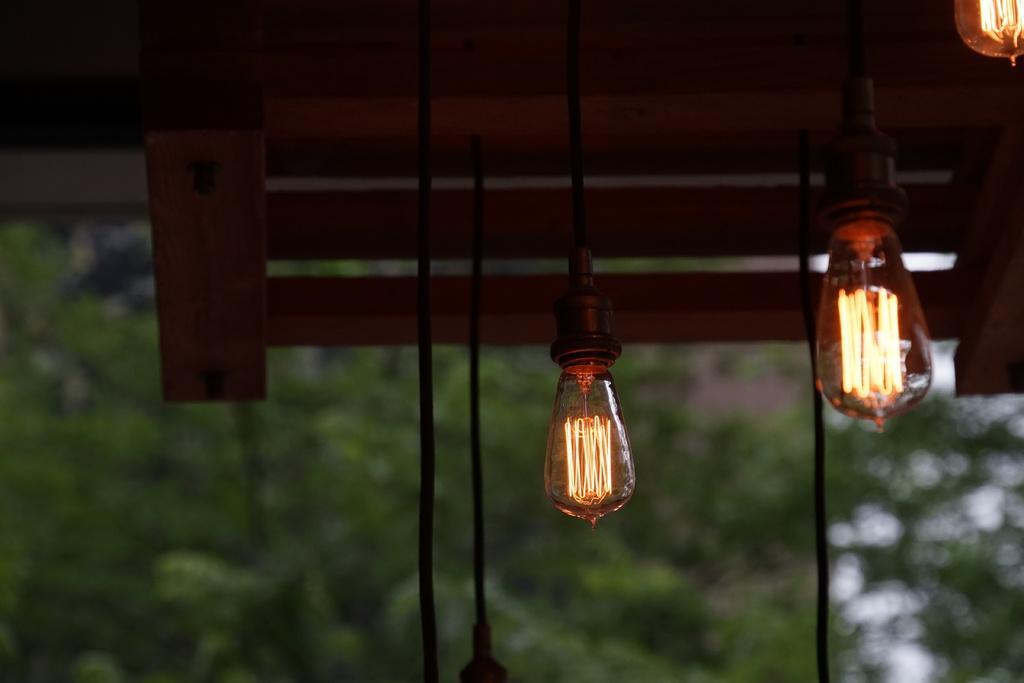How would you summarize this image in a sentence or two? In the image there are lights hanged down and the background of the lights is blue. 